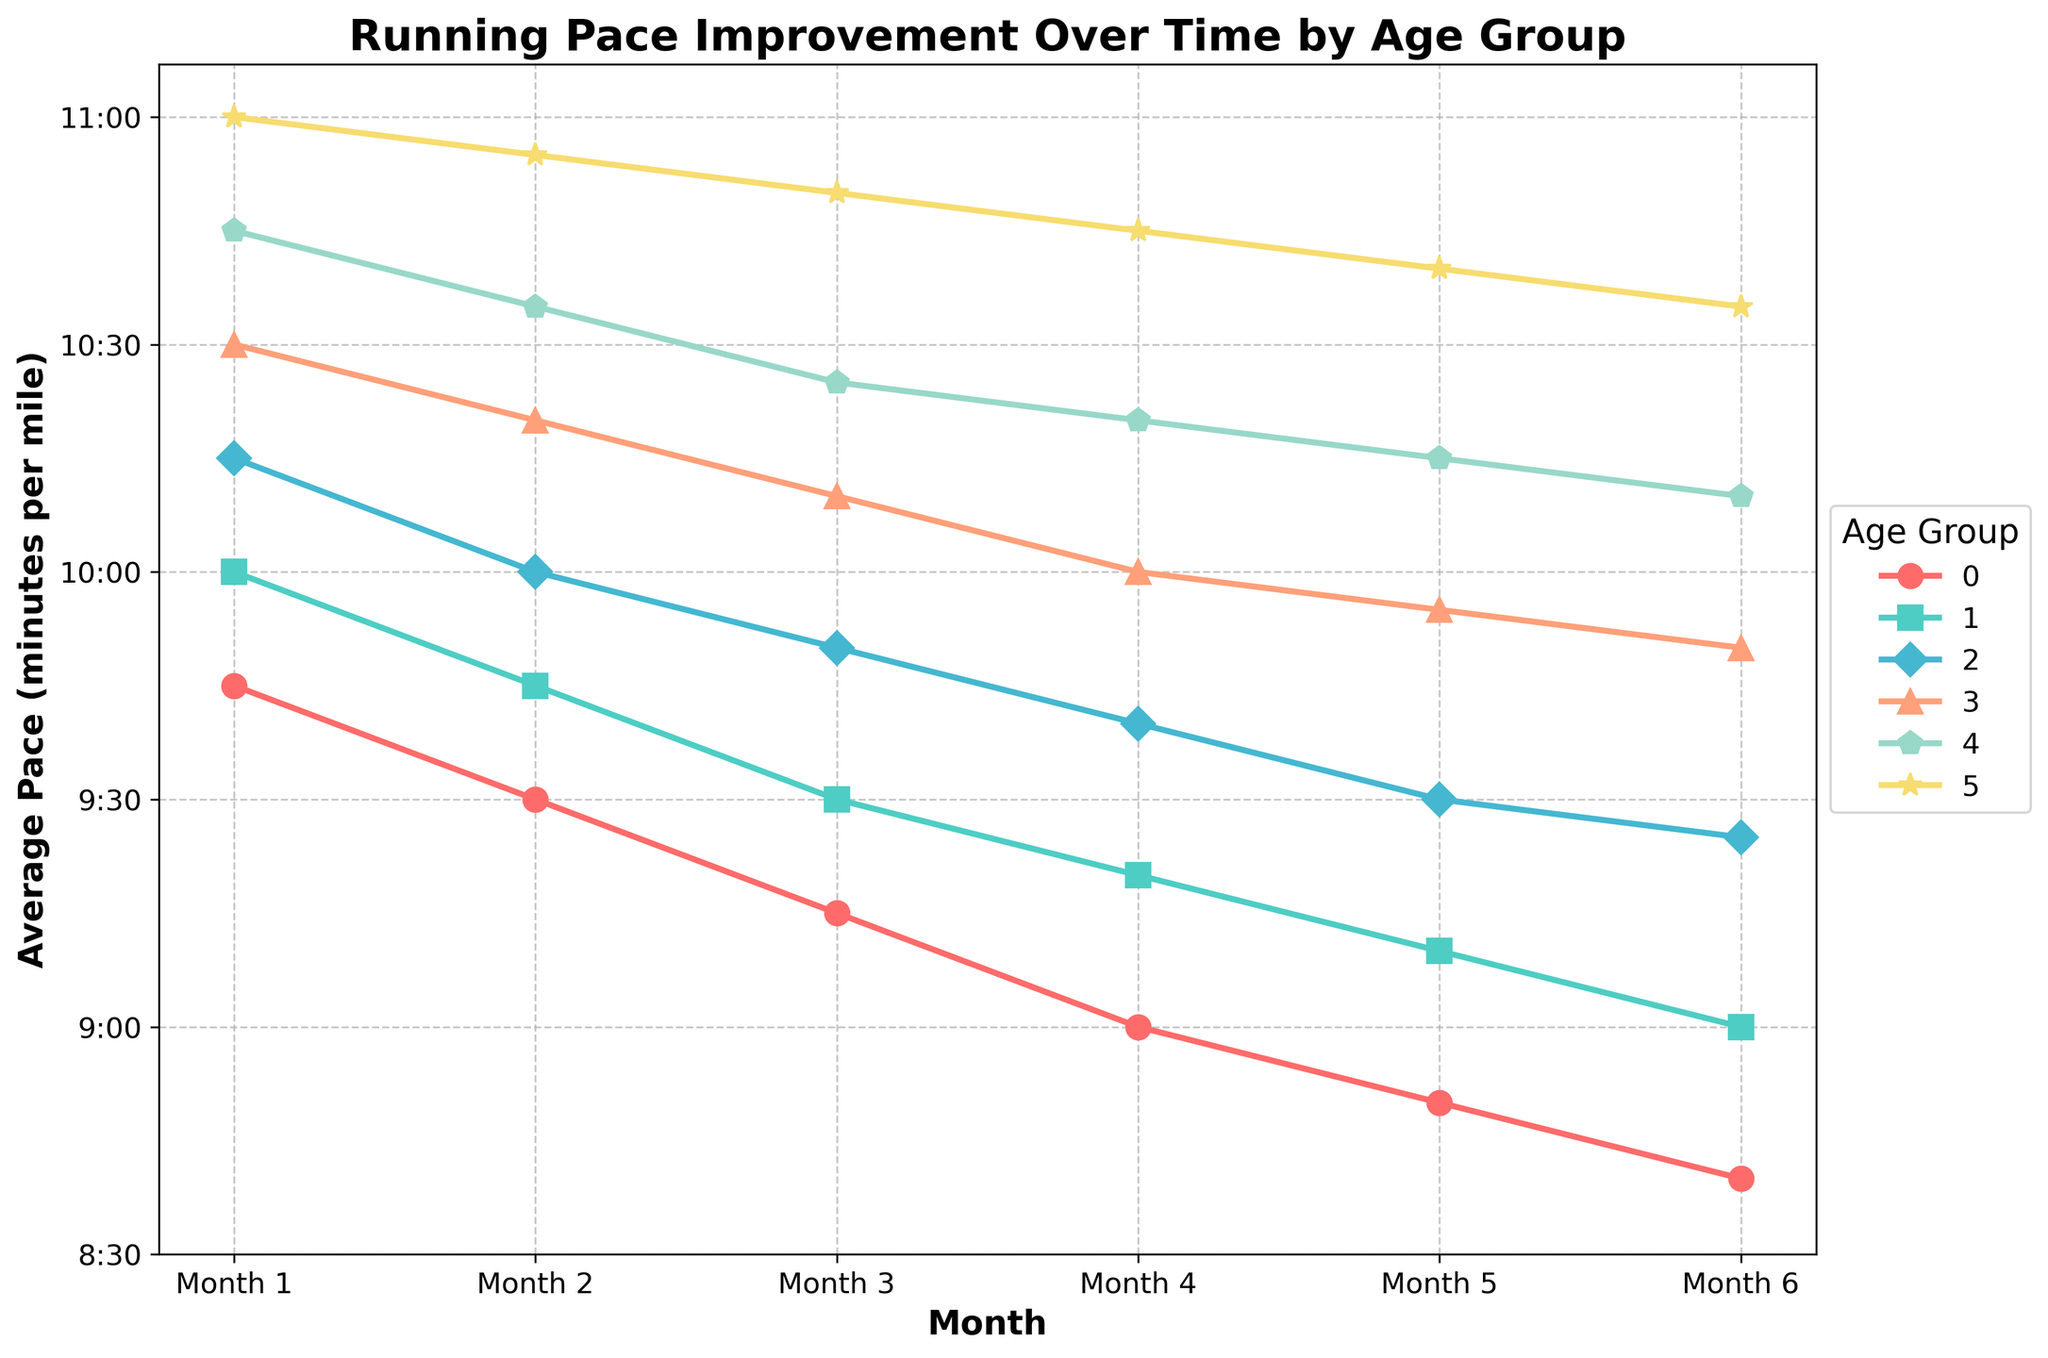What is the trend of running pace improvement for the 18-25 age group? The 18-25 age group starts at 9:45 in Month 1 and improves consistently over the months, reaching 8:40 in Month 6. This shows a steady decline in pace time, indicating improved running speed.
Answer: Steady improvement, reaching 8:40 in Month 6 Which age group shows the least improvement in their average running pace over the six months? The 65+ age group shows the least improvement, starting at 11:00 and improving to 10:35 in Month 6. A difference of only 25 seconds indicates the smallest pace improvement.
Answer: 65+ age group Among all age groups, which one had the fastest average pace in Month 6? By examining the final points in Month 6 for all the age groups, the 18-25 age group had the fastest average pace, clocking in at 8:40.
Answer: 18-25 age group What is the difference in running pace improvements between the 18-25 and 26-35 age groups by Month 6? The 18-25 age group improved from 9:45 to 8:40, a 1:05 improvement. The 26-35 group improved from 10:00 to 9:00, a 1:00 improvement. Therefore, the 18-25 age group had a 5-second greater improvement.
Answer: 5 seconds Which age group had the most significant decline in pace from Month 5 to Month 6? Comparing the pace from Month 5 to Month 6 for all groups, the 36-45 age group had a notable improvement from 9:30 to 9:25, which is a 5 seconds improvement, while other age groups showed less change.
Answer: 36-45 age group Between the 18-25 and 46-55 age groups, who had a faster pace in Month 3, and what is the difference? In Month 3, the 18-25 pace is 9:15, and the 46-55 pace is 10:10. The difference in pace is 55 seconds favoring the 18-25 age group.
Answer: 18-25 age group, 55 seconds By Month 6, how many seconds did the average pace of the 56-65 age group reduce from its initial pace? The 56-65 age group starts at 10:45 and reaches 10:10 in Month 6. The reduction is 35 seconds.
Answer: 35 seconds Visually, which age group is represented by a green color line in the chart? The green line represents the 26-35 age group in the chart, indicated by the legend and the visually distinctive green color line among the plotted lines.
Answer: 26-35 age group How much faster is the average pace of the 36-45 age group compared to the 56-65 age group in Month 4? In Month 4, the 36-45 age group has a pace of 9:40, and the 56-65 age group has a pace of 10:20. The 36-45 group is 40 seconds faster.
Answer: 40 seconds 